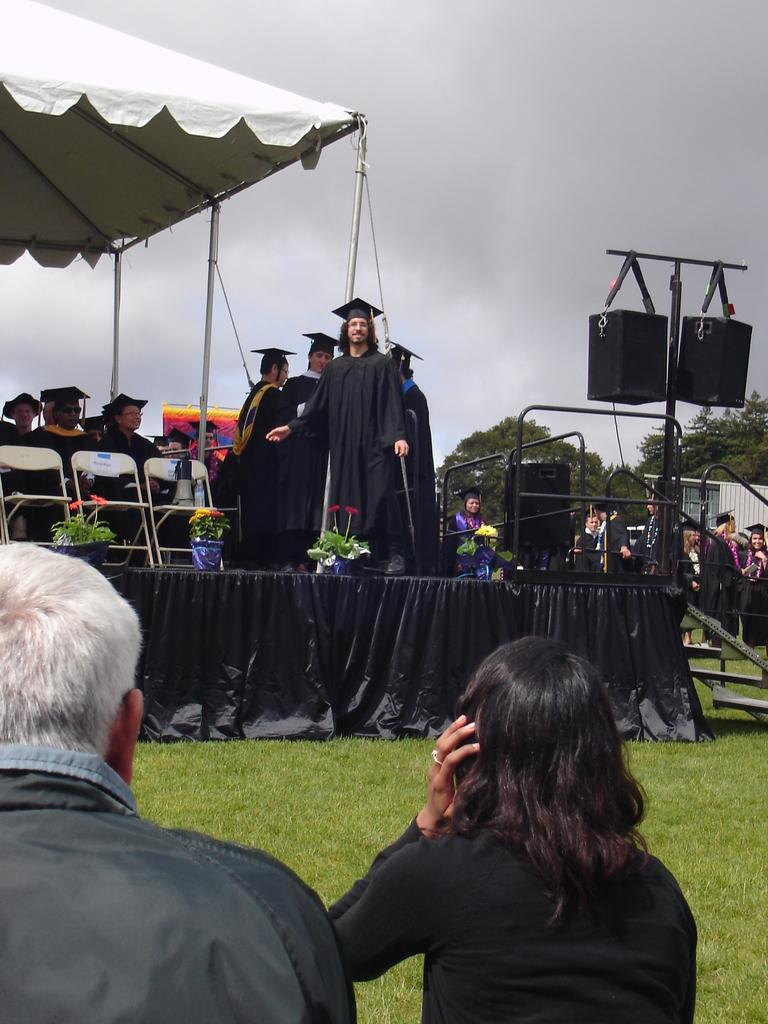Who or what is present in the image? There are people in the image. What type of clothing can be seen in the image? There is black color cloth in the image. What type of furniture is visible in the image? There are chairs in the image. What type of natural environment is visible in the image? There are trees in the image. What part of the natural environment is visible in the image? The sky is visible in the image. What committee is meeting in the image? There is no committee meeting in the image; it simply shows people, black color cloth, chairs, trees, and the sky. 